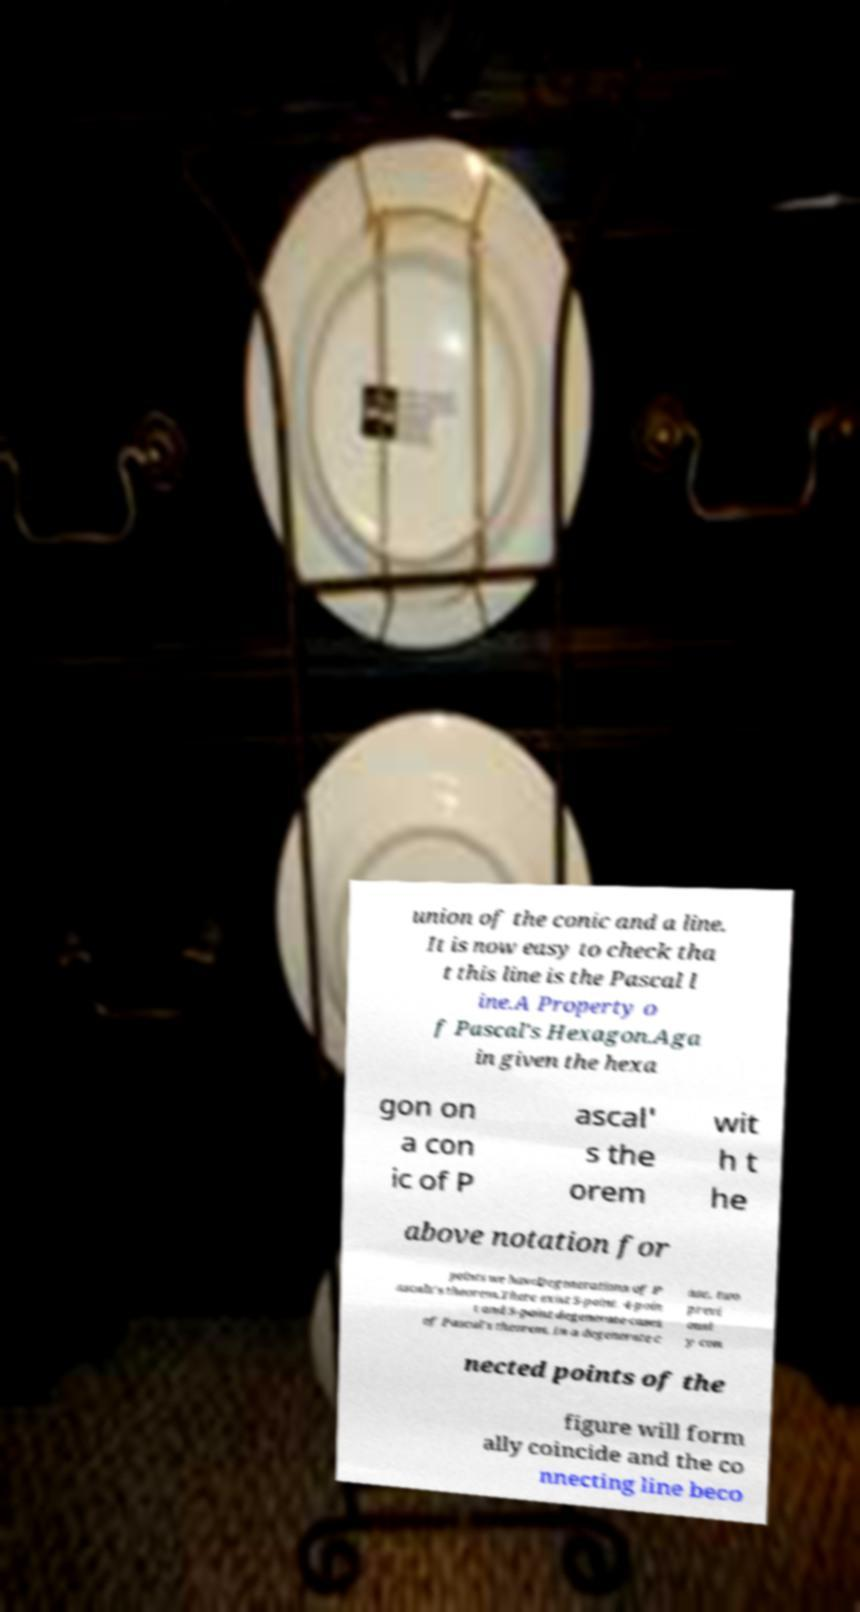Could you assist in decoding the text presented in this image and type it out clearly? union of the conic and a line. It is now easy to check tha t this line is the Pascal l ine.A Property o f Pascal's Hexagon.Aga in given the hexa gon on a con ic of P ascal' s the orem wit h t he above notation for points we haveDegenerations of P ascals's theorem.There exist 5-point, 4-poin t and 3-point degenerate cases of Pascal's theorem. In a degenerate c ase, two previ ousl y con nected points of the figure will form ally coincide and the co nnecting line beco 